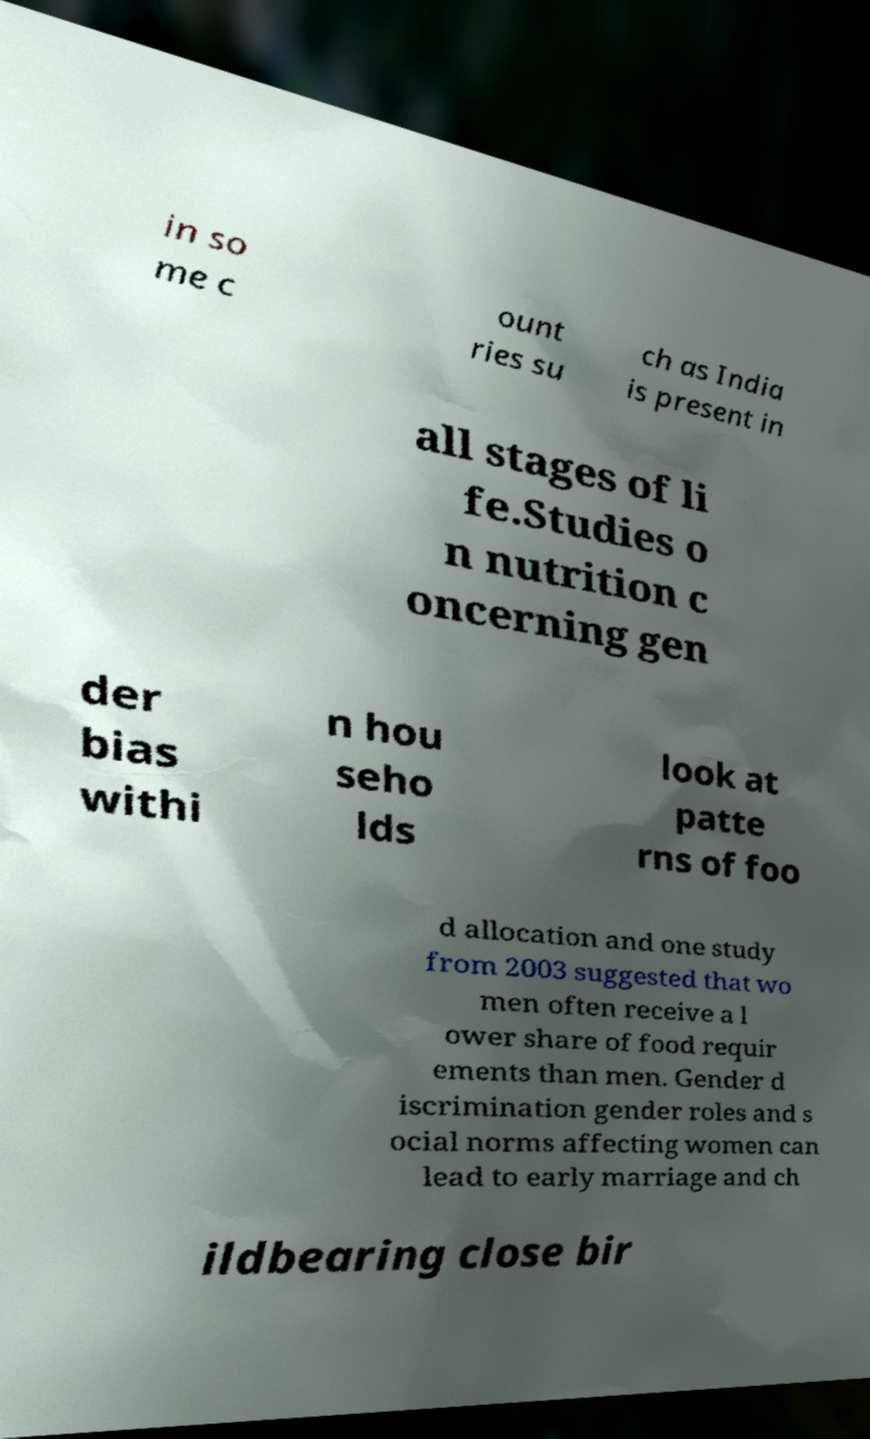For documentation purposes, I need the text within this image transcribed. Could you provide that? in so me c ount ries su ch as India is present in all stages of li fe.Studies o n nutrition c oncerning gen der bias withi n hou seho lds look at patte rns of foo d allocation and one study from 2003 suggested that wo men often receive a l ower share of food requir ements than men. Gender d iscrimination gender roles and s ocial norms affecting women can lead to early marriage and ch ildbearing close bir 